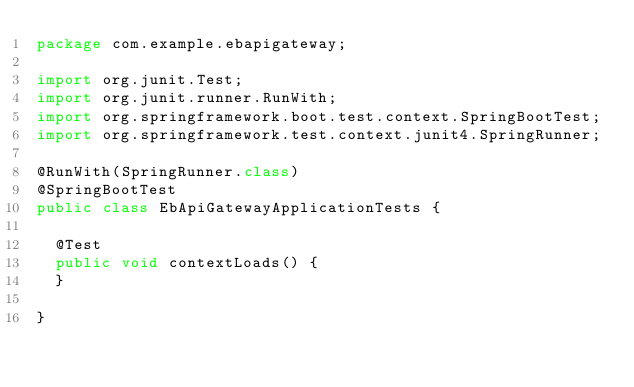<code> <loc_0><loc_0><loc_500><loc_500><_Java_>package com.example.ebapigateway;

import org.junit.Test;
import org.junit.runner.RunWith;
import org.springframework.boot.test.context.SpringBootTest;
import org.springframework.test.context.junit4.SpringRunner;

@RunWith(SpringRunner.class)
@SpringBootTest
public class EbApiGatewayApplicationTests {

	@Test
	public void contextLoads() {
	}

}
</code> 